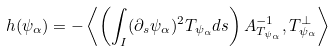<formula> <loc_0><loc_0><loc_500><loc_500>h ( \psi _ { \alpha } ) = - \left < \left ( \int _ { I } ( \partial _ { s } \psi _ { \alpha } ) ^ { 2 } T _ { \psi _ { \alpha } } d s \right ) A _ { T _ { \psi _ { \alpha } } } ^ { - 1 } , T _ { \psi _ { \alpha } } ^ { \perp } \right ></formula> 